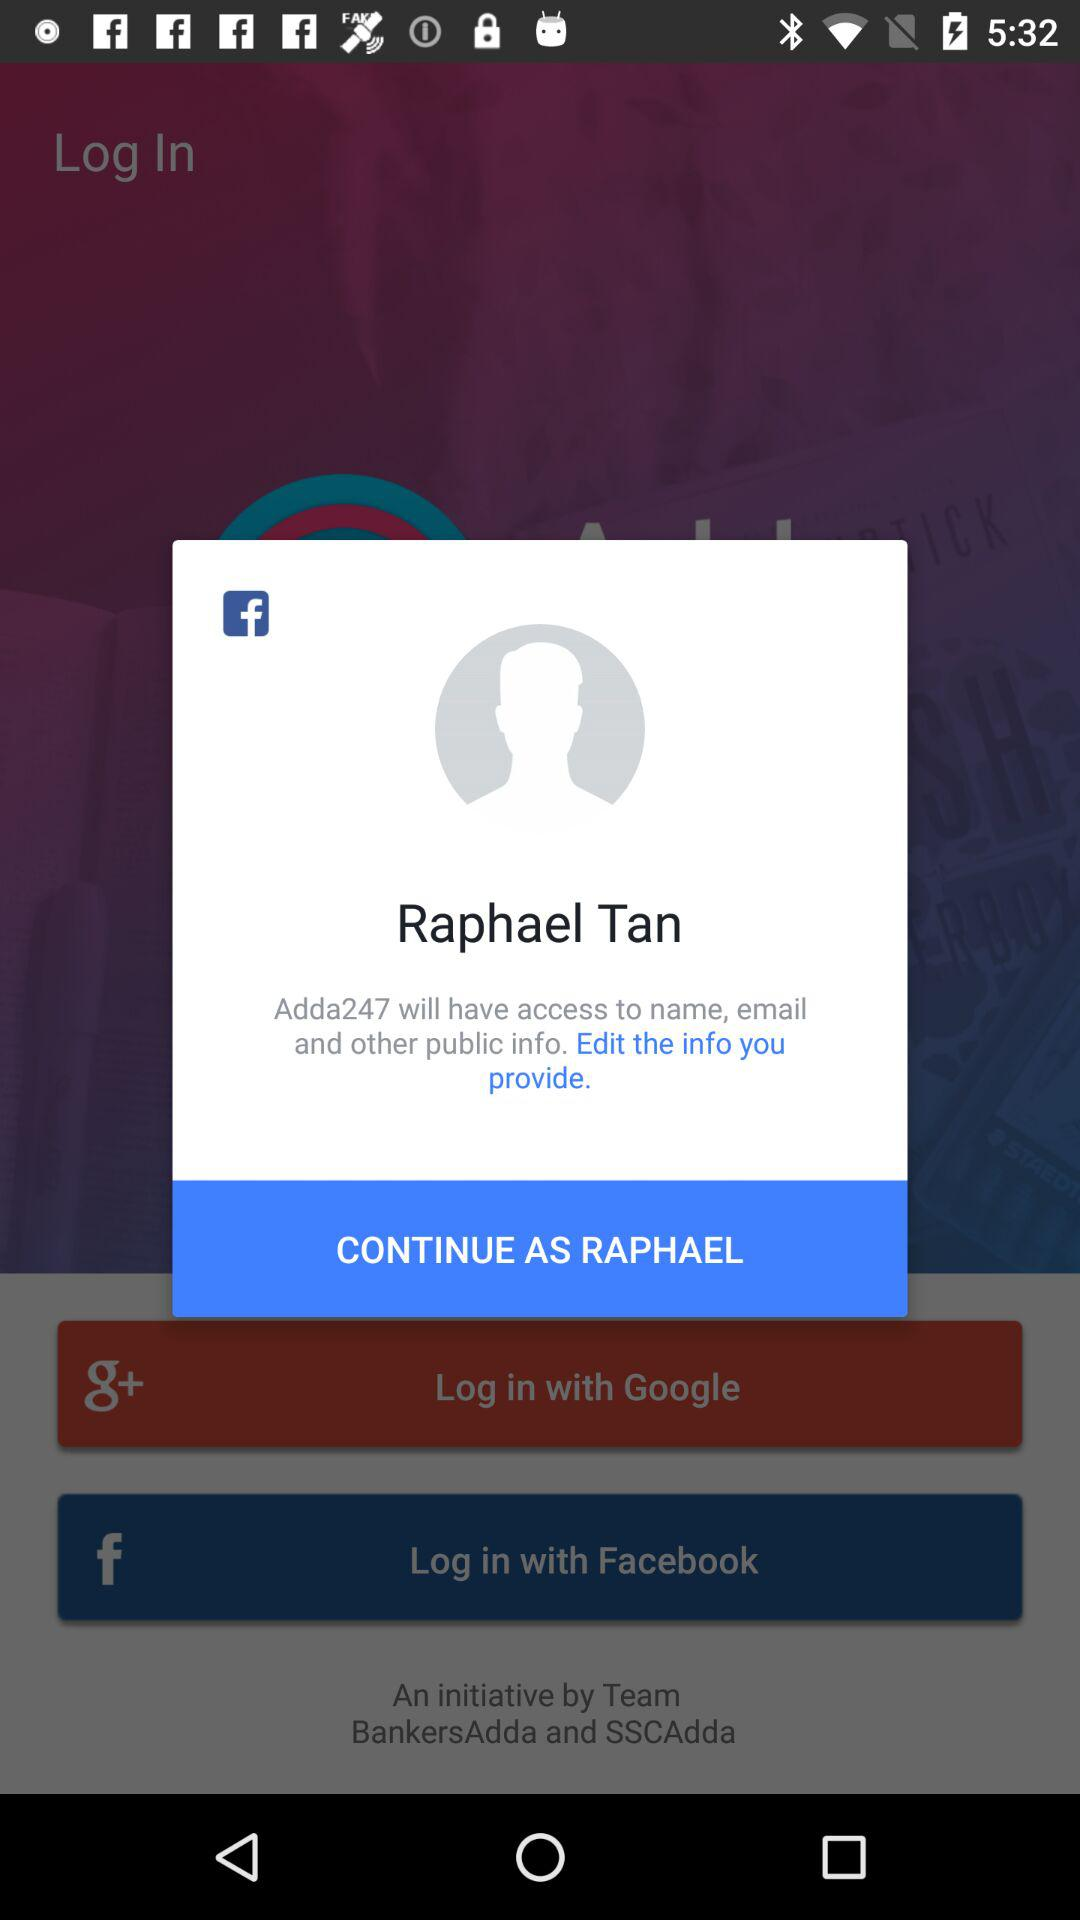What is the name of the user? The user name is Raphael Tan. 